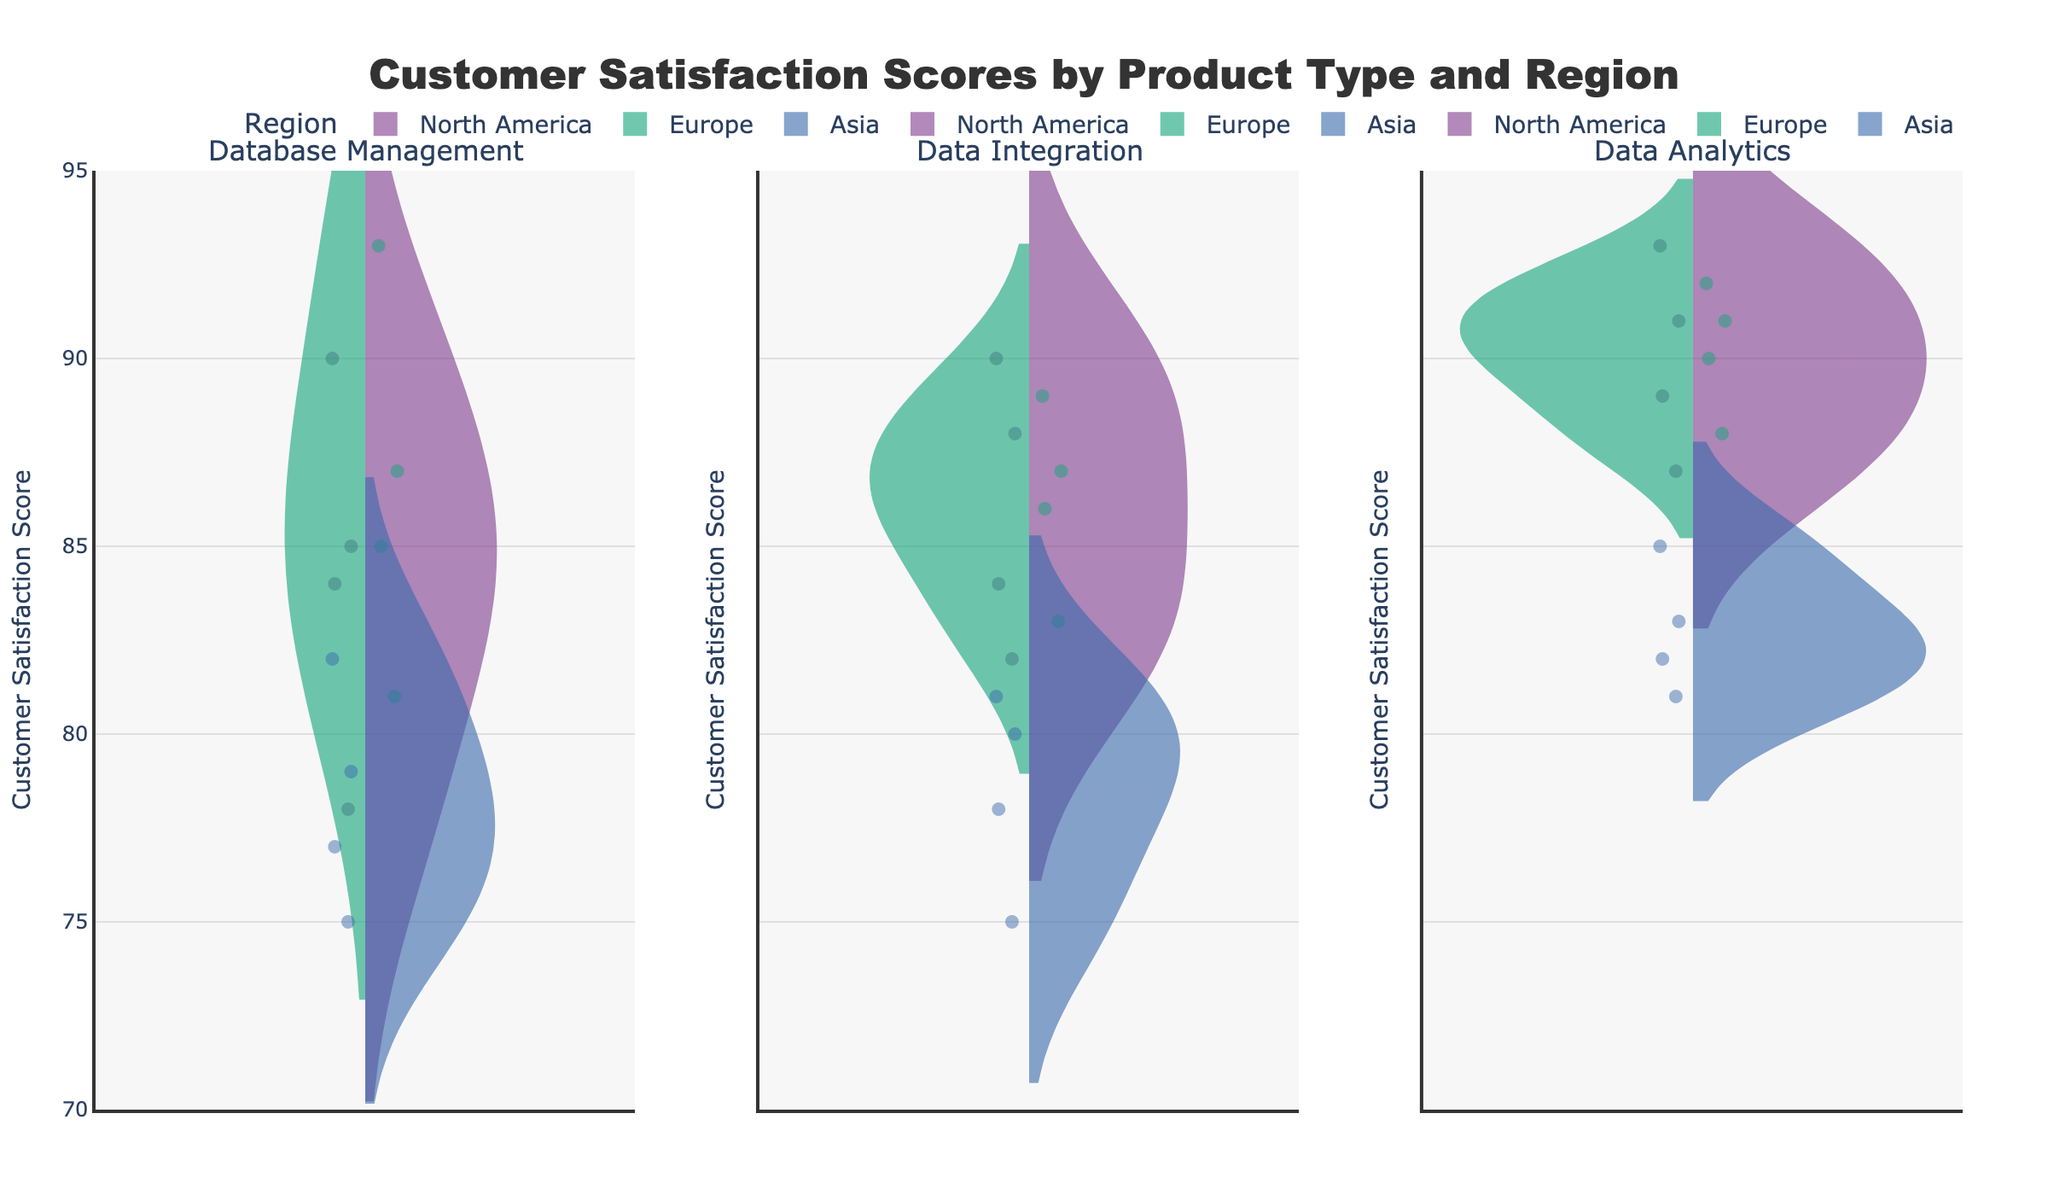What is the title of the figure? The title of the figure is displayed prominently at the top of the plot. It reads "Customer Satisfaction Scores by Product Type and Region".
Answer: Customer Satisfaction Scores by Product Type and Region How many subplots are there, and what do they represent? There are three subplots, and they represent the three different product types: Database Management, Data Integration, and Data Analytics. Each subplot compares customer satisfaction scores by region for one product type.
Answer: 3 subplots, representing Database Management, Data Integration, and Data Analytics Which region has the highest average customer satisfaction score for Data Analytics? To find the highest average customer satisfaction score for Data Analytics, look at the mean lines of all three regions within the Data Analytics subplot. The mean line for Europe is the highest among the three.
Answer: Europe What is the range of customer satisfaction scores displayed on the y-axis? The range of customer satisfaction scores displayed on the y-axis can be read directly from the axis itself, which ranges from 70 to 95.
Answer: 70 to 95 Between North America and Asia, which region has the wider spread of customer satisfaction scores for Database Management? To determine the region with the wider spread, compare the width and shape of the violins for North America and Asia in the Database Management subplot. Asia has a wider spread compared to North America.
Answer: Asia Which product type shows the smallest variation in customer satisfaction scores across all regions? The smallest variation can be identified by comparing the width of the violins across all subplots. Data Analytics shows the smallest variation as its violins for all regions are relatively narrow and close to each other.
Answer: Data Analytics What are the mean customer satisfaction scores for North America for Data Integration and Data Analytics? Observing the mean line within the violins for North America in both Data Integration and Data Analytics subplots, Data Integration has a mean around 86 and Data Analytics has a mean around 90.
Answer: Data Integration: 86, Data Analytics: 90 Which product type and region combination has the highest individual customer satisfaction score? By checking the highest points within each violin across all subplots, Data Analytics in North America has the highest individual customer satisfaction score of 93.
Answer: Data Analytics in North America Are there any regions where the mean customer satisfaction score is the same for more than one product type? If so, which regions and product types? To determine if there are regions with the same mean score for more than one product type, compare the mean lines. In Europe, both Data Integration and Database Management have very close mean scores around 86-87.
Answer: Europe: Data Integration and Database Management 